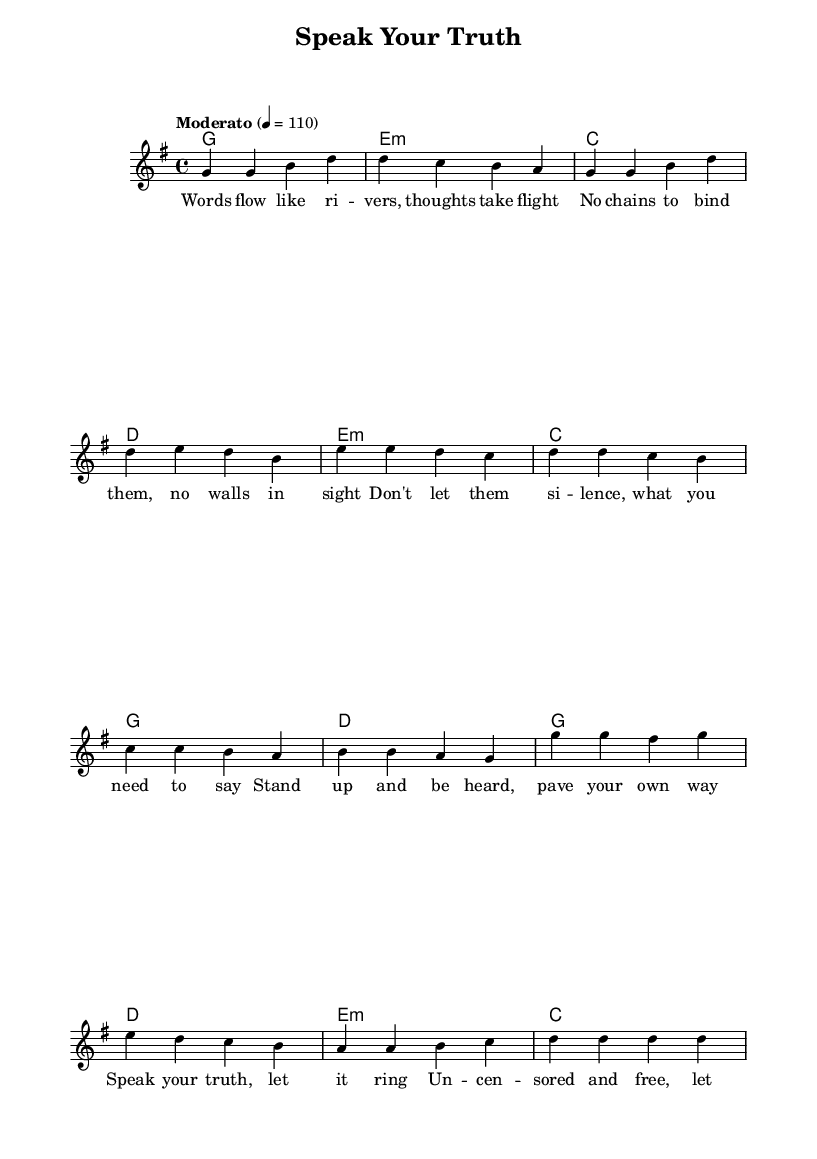What is the key signature of this music? The key signature appears at the beginning of the staff, which indicates G major, shown by one sharp (F#).
Answer: G major What is the time signature of this music? The time signature is located at the beginning of the music, indicating that there are 4 beats in each measure, shown as 4/4.
Answer: 4/4 What is the tempo marking for this piece? The tempo marking is indicated with "Moderato" followed by a metronome mark of 4 = 110, indicating the speed of the piece.
Answer: Moderato How many measures are in the verse? Counting the measures in the verse section of the sheet music, there are four distinct measures before the pre-chorus begins.
Answer: Four What chord follows the first chorus? The first chorus ends with a C major chord based on the chord progression shown in the harmonies.
Answer: C major What is the primary theme of the lyrics? The lyrics focus on freedom of expression and encourage individuals to speak their truth without fear, which is reflected in the verses, pre-chorus, and chorus.
Answer: Freedom of expression How do the lyrics relate to the overall structure of the song? The lyrics are organized into three main sections: the verse, pre-chorus, and chorus, each contributing to the song's narrative of empowerment and uncensored expression, following a typical pop structure.
Answer: Empowerment and uncensored expression 